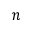<formula> <loc_0><loc_0><loc_500><loc_500>n</formula> 